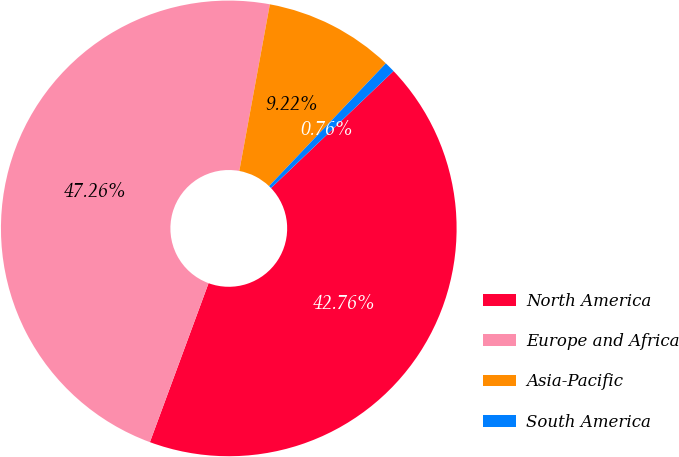Convert chart to OTSL. <chart><loc_0><loc_0><loc_500><loc_500><pie_chart><fcel>North America<fcel>Europe and Africa<fcel>Asia-Pacific<fcel>South America<nl><fcel>42.76%<fcel>47.26%<fcel>9.22%<fcel>0.76%<nl></chart> 